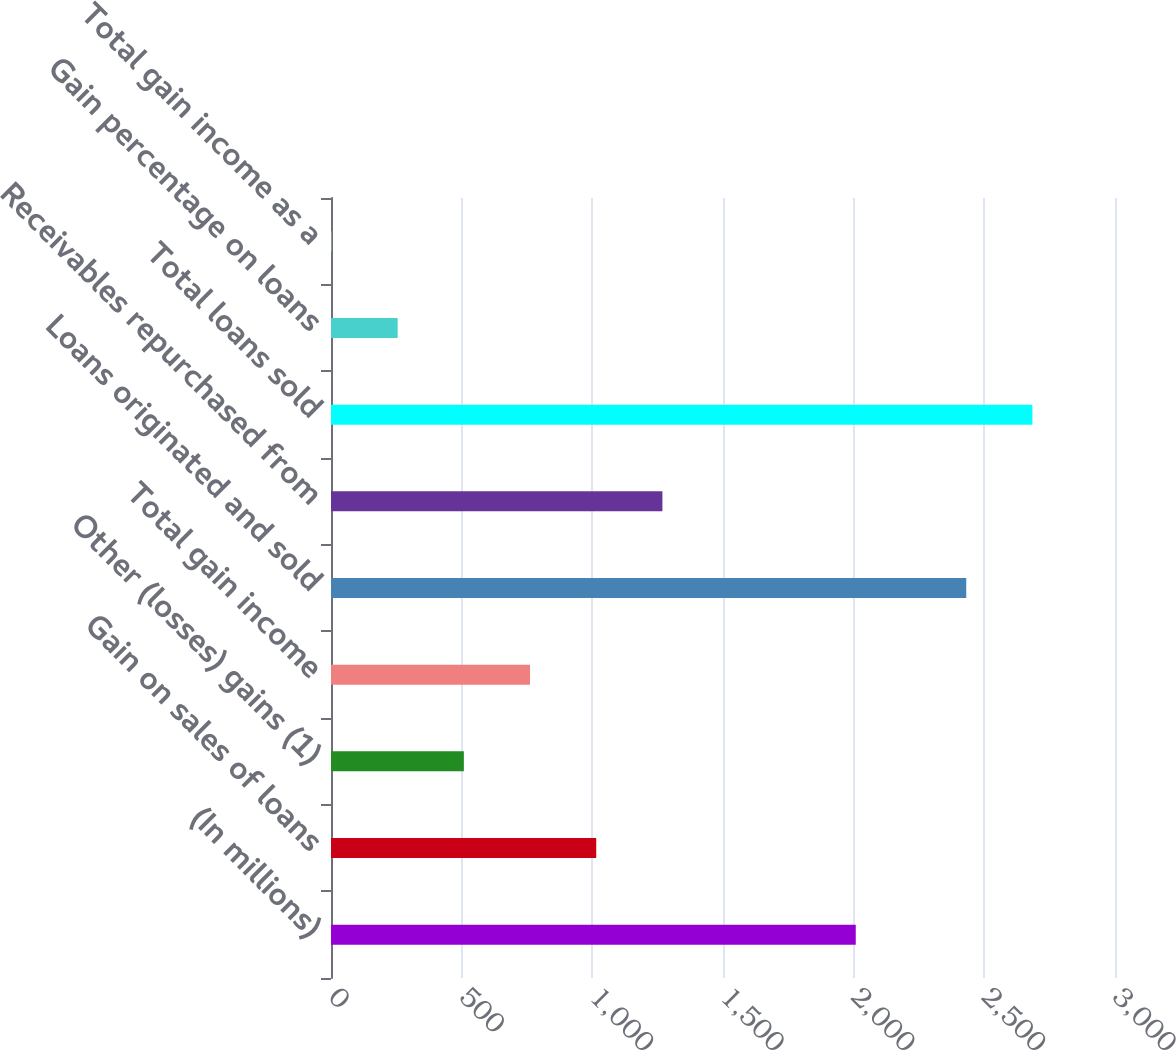Convert chart. <chart><loc_0><loc_0><loc_500><loc_500><bar_chart><fcel>(In millions)<fcel>Gain on sales of loans<fcel>Other (losses) gains (1)<fcel>Total gain income<fcel>Loans originated and sold<fcel>Receivables repurchased from<fcel>Total loans sold<fcel>Gain percentage on loans<fcel>Total gain income as a<nl><fcel>2008<fcel>1014.9<fcel>508.4<fcel>761.65<fcel>2430.8<fcel>1268.15<fcel>2684.05<fcel>255.15<fcel>1.9<nl></chart> 